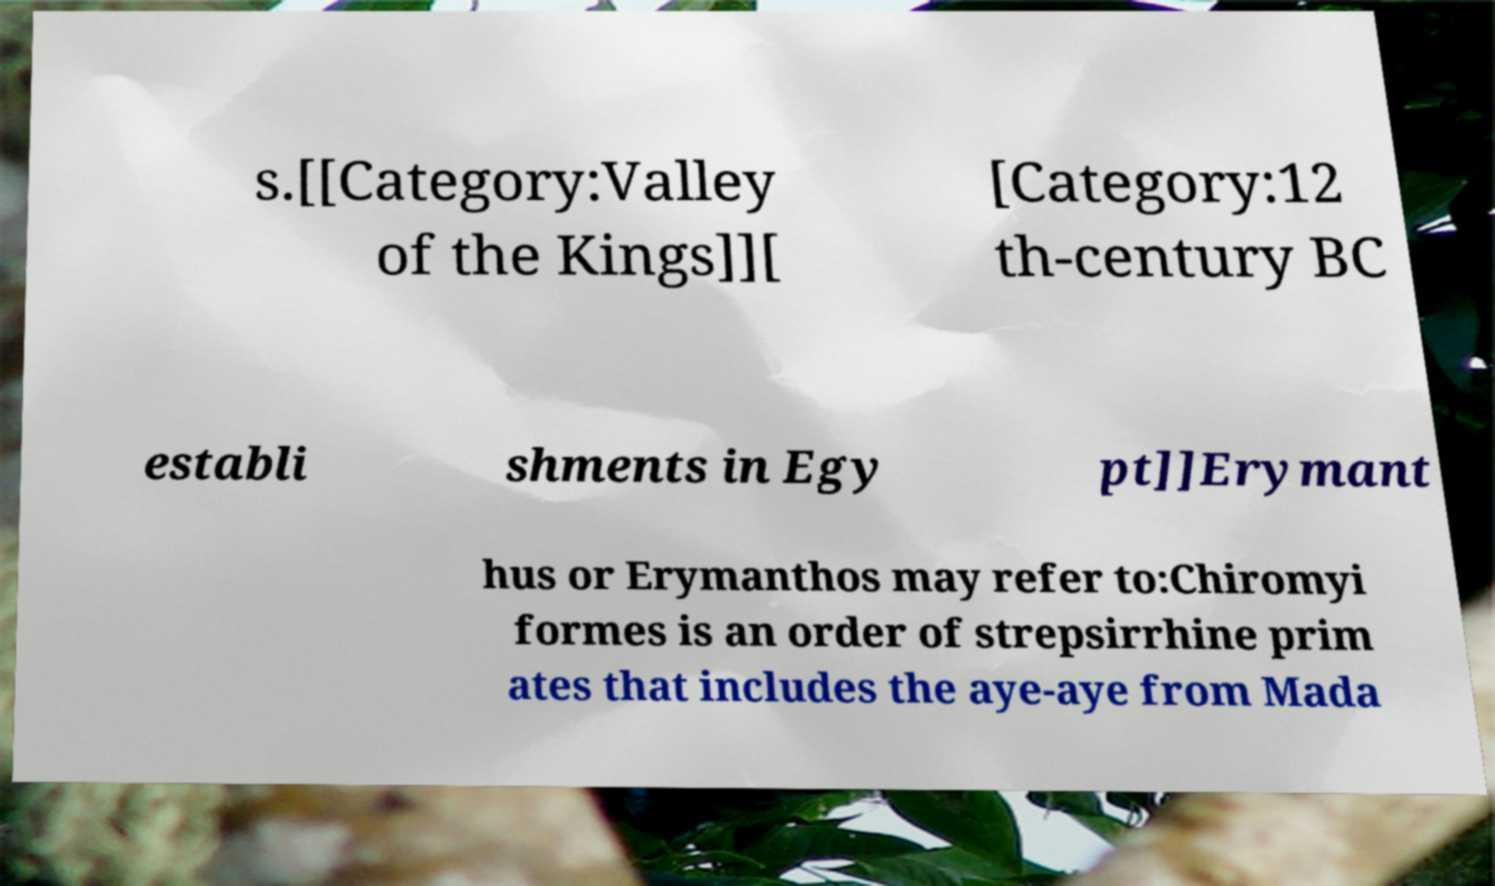There's text embedded in this image that I need extracted. Can you transcribe it verbatim? s.[[Category:Valley of the Kings]][ [Category:12 th-century BC establi shments in Egy pt]]Erymant hus or Erymanthos may refer to:Chiromyi formes is an order of strepsirrhine prim ates that includes the aye-aye from Mada 